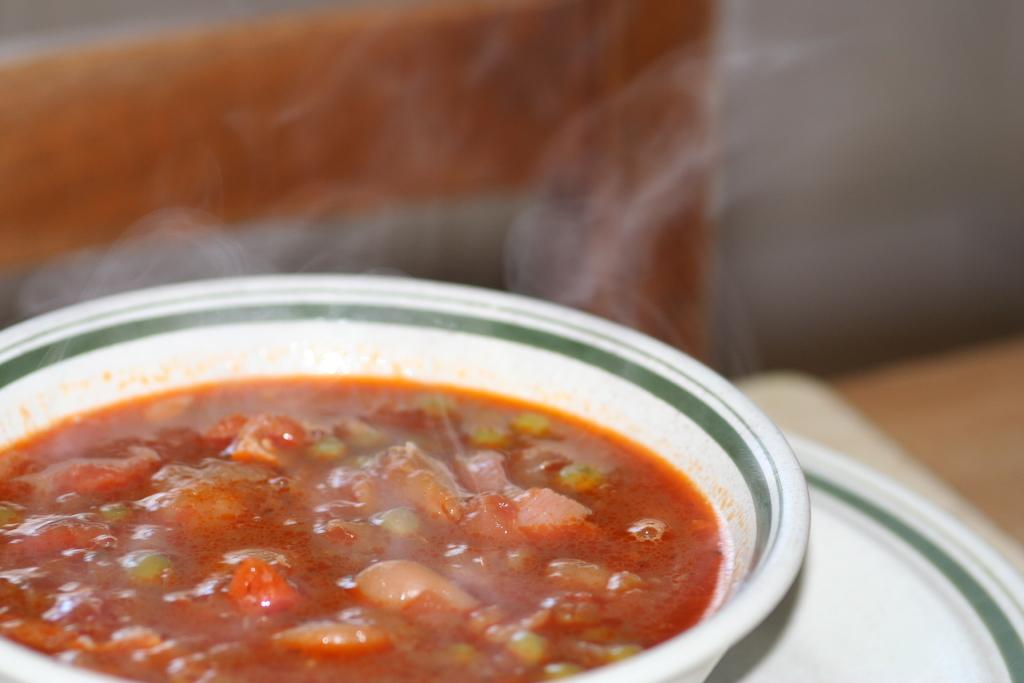What is the food item in the bowl on the plate? The specific food item is not mentioned in the facts, but there is a food item in a bowl on a plate. Where is the plate with the bowl located? The plate with the bowl is on a platform. What can be seen in the background of the image? In the background, there is smoke, a chair, and a wall. What type of leather is the lawyer using to make their current case? There is no lawyer, leather, or case present in the image. 